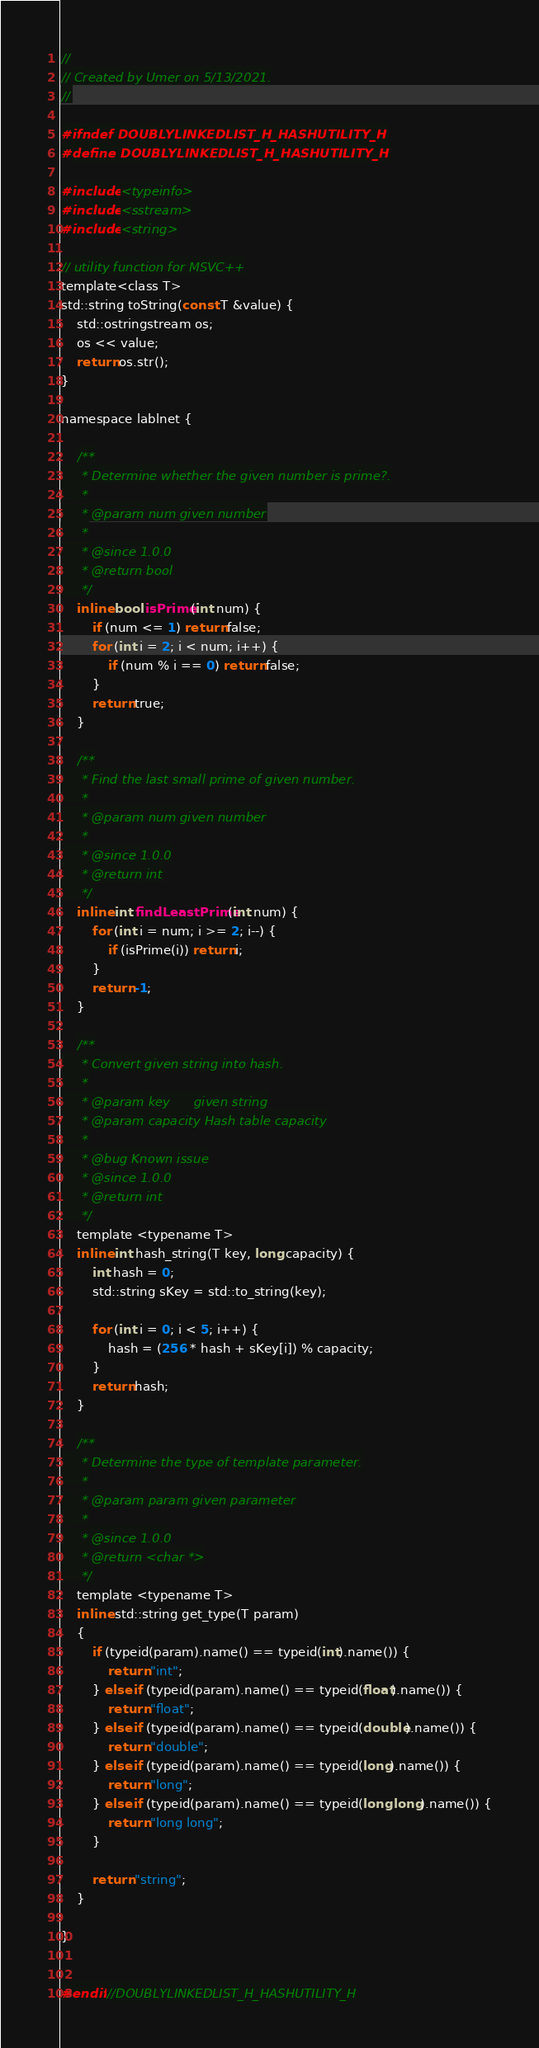Convert code to text. <code><loc_0><loc_0><loc_500><loc_500><_C_>//
// Created by Umer on 5/13/2021.
//

#ifndef DOUBLYLINKEDLIST_H_HASHUTILITY_H
#define DOUBLYLINKEDLIST_H_HASHUTILITY_H

#include <typeinfo>
#include <sstream>
#include <string>

// utility function for MSVC++
template<class T>
std::string toString(const T &value) {
    std::ostringstream os;
    os << value;
    return os.str();
}

namespace lablnet {

    /**
     * Determine whether the given number is prime?.
     *
     * @param num given number
     *
     * @since 1.0.0
     * @return bool
     */
    inline bool isPrime(int num) {
        if (num <= 1) return false;
        for (int i = 2; i < num; i++) {
            if (num % i == 0) return false;
        }
        return true;
    }

    /**
     * Find the last small prime of given number.
     *
     * @param num given number
     *
     * @since 1.0.0
     * @return int
     */
    inline int findLeastPrime(int num) {
        for (int i = num; i >= 2; i--) {
            if (isPrime(i)) return i;
        }
        return -1;
    }

    /**
     * Convert given string into hash.
     *
     * @param key      given string
     * @param capacity Hash table capacity
     *
     * @bug Known issue
     * @since 1.0.0
     * @return int
     */
    template <typename T>
    inline int hash_string(T key, long capacity) {
        int hash = 0;
        std::string sKey = std::to_string(key);

        for (int i = 0; i < 5; i++) {
            hash = (256 * hash + sKey[i]) % capacity;
        }
        return hash;
    }

    /**
     * Determine the type of template parameter.
     *
     * @param param given parameter
     *
     * @since 1.0.0
     * @return <char *>
     */
    template <typename T>
    inline std::string get_type(T param)
    {
        if (typeid(param).name() == typeid(int).name()) {
            return "int";
        } else if (typeid(param).name() == typeid(float).name()) {
            return "float";
        } else if (typeid(param).name() == typeid(double).name()) {
            return "double";
        } else if (typeid(param).name() == typeid(long).name()) {
            return "long";
        } else if (typeid(param).name() == typeid(long long).name()) {
            return "long long";
        }

        return "string";
    }

}


#endif //DOUBLYLINKEDLIST_H_HASHUTILITY_H
</code> 